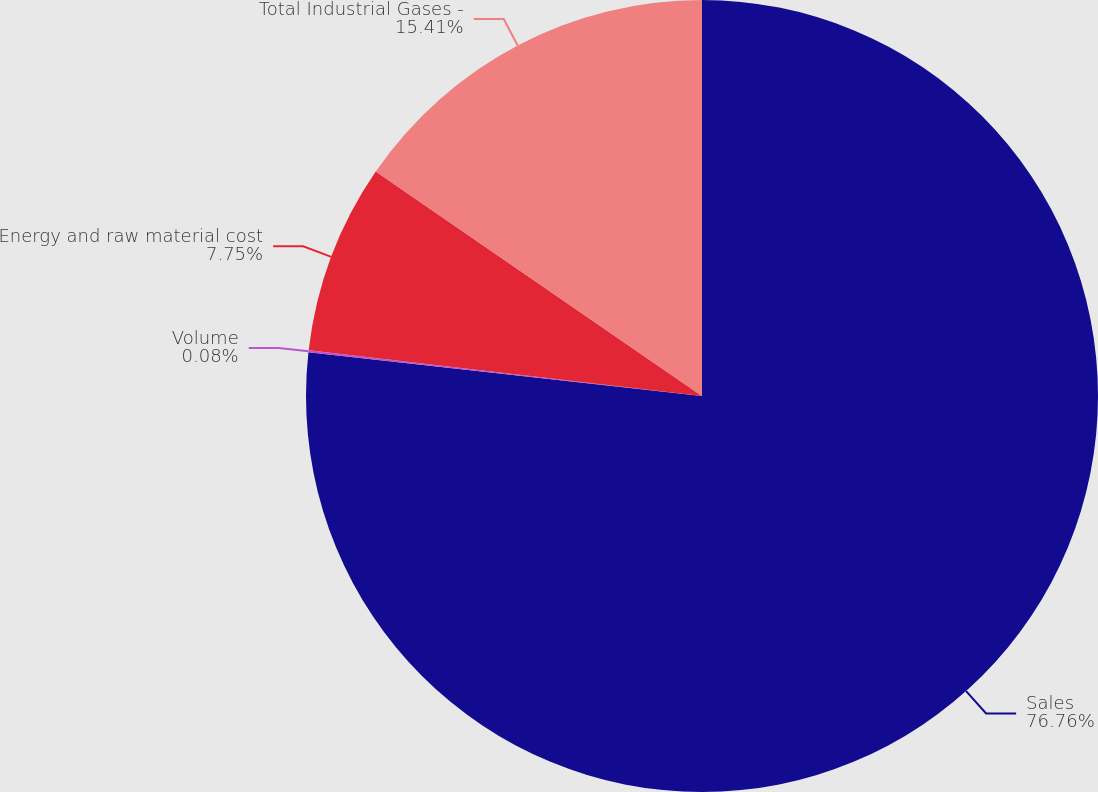Convert chart. <chart><loc_0><loc_0><loc_500><loc_500><pie_chart><fcel>Sales<fcel>Volume<fcel>Energy and raw material cost<fcel>Total Industrial Gases -<nl><fcel>76.76%<fcel>0.08%<fcel>7.75%<fcel>15.41%<nl></chart> 